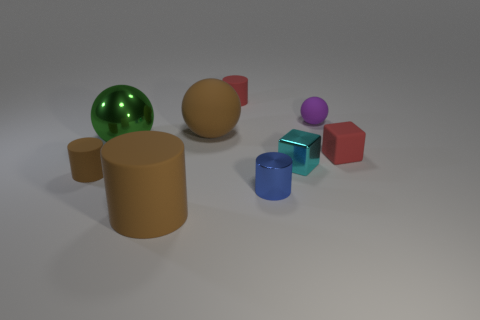There is a large thing that is behind the big metallic ball; is it the same color as the cube that is behind the small cyan block?
Your answer should be compact. No. There is a rubber cylinder that is the same color as the tiny matte block; what is its size?
Your answer should be compact. Small. Is there a brown thing made of the same material as the tiny blue cylinder?
Provide a short and direct response. No. Are there the same number of metallic objects that are to the right of the large metallic object and cyan objects on the left side of the red cylinder?
Provide a succinct answer. No. What is the size of the brown cylinder behind the big cylinder?
Keep it short and to the point. Small. What material is the small red object in front of the tiny matte cylinder that is right of the big metallic thing made of?
Your answer should be very brief. Rubber. How many small red rubber things are behind the big brown object that is behind the tiny blue metal object that is in front of the brown rubber ball?
Your answer should be very brief. 1. Does the large object that is in front of the large green thing have the same material as the small cylinder behind the tiny brown cylinder?
Keep it short and to the point. Yes. There is a big object that is the same color as the large rubber cylinder; what material is it?
Ensure brevity in your answer.  Rubber. What number of brown objects are the same shape as the tiny purple matte object?
Provide a short and direct response. 1. 